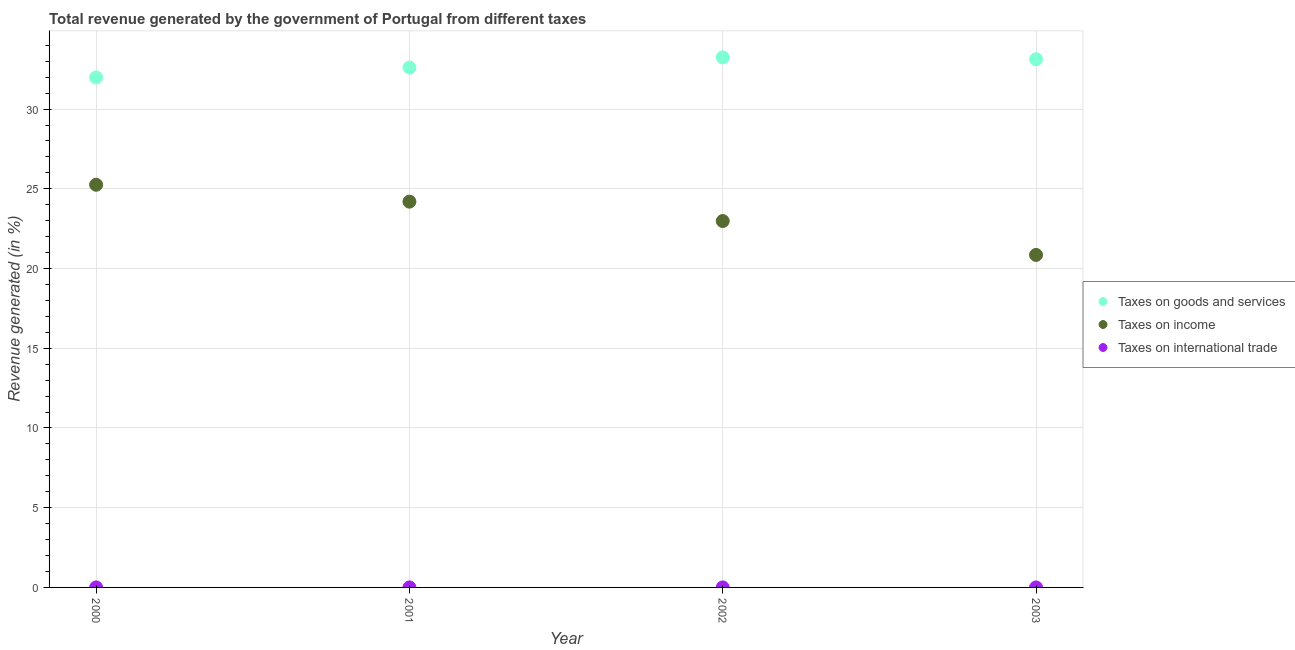How many different coloured dotlines are there?
Provide a short and direct response. 3. Is the number of dotlines equal to the number of legend labels?
Provide a succinct answer. Yes. What is the percentage of revenue generated by tax on international trade in 2000?
Your answer should be compact. 0. Across all years, what is the maximum percentage of revenue generated by taxes on income?
Your answer should be very brief. 25.25. Across all years, what is the minimum percentage of revenue generated by tax on international trade?
Offer a very short reply. 0. What is the total percentage of revenue generated by taxes on goods and services in the graph?
Keep it short and to the point. 130.96. What is the difference between the percentage of revenue generated by taxes on income in 2000 and that in 2002?
Offer a terse response. 2.28. What is the difference between the percentage of revenue generated by tax on international trade in 2002 and the percentage of revenue generated by taxes on income in 2000?
Your answer should be compact. -25.25. What is the average percentage of revenue generated by tax on international trade per year?
Your response must be concise. 0. In the year 2003, what is the difference between the percentage of revenue generated by tax on international trade and percentage of revenue generated by taxes on goods and services?
Offer a terse response. -33.12. In how many years, is the percentage of revenue generated by tax on international trade greater than 8 %?
Ensure brevity in your answer.  0. What is the ratio of the percentage of revenue generated by taxes on goods and services in 2002 to that in 2003?
Give a very brief answer. 1. Is the difference between the percentage of revenue generated by tax on international trade in 2002 and 2003 greater than the difference between the percentage of revenue generated by taxes on income in 2002 and 2003?
Ensure brevity in your answer.  No. What is the difference between the highest and the second highest percentage of revenue generated by taxes on income?
Your answer should be compact. 1.06. What is the difference between the highest and the lowest percentage of revenue generated by taxes on goods and services?
Offer a very short reply. 1.26. Does the percentage of revenue generated by taxes on income monotonically increase over the years?
Your answer should be compact. No. Is the percentage of revenue generated by tax on international trade strictly greater than the percentage of revenue generated by taxes on income over the years?
Offer a terse response. No. Is the percentage of revenue generated by taxes on goods and services strictly less than the percentage of revenue generated by tax on international trade over the years?
Offer a terse response. No. How many dotlines are there?
Offer a terse response. 3. How are the legend labels stacked?
Provide a short and direct response. Vertical. What is the title of the graph?
Give a very brief answer. Total revenue generated by the government of Portugal from different taxes. Does "Grants" appear as one of the legend labels in the graph?
Give a very brief answer. No. What is the label or title of the Y-axis?
Offer a very short reply. Revenue generated (in %). What is the Revenue generated (in %) of Taxes on goods and services in 2000?
Your answer should be compact. 31.98. What is the Revenue generated (in %) of Taxes on income in 2000?
Your answer should be compact. 25.25. What is the Revenue generated (in %) of Taxes on international trade in 2000?
Make the answer very short. 0. What is the Revenue generated (in %) of Taxes on goods and services in 2001?
Give a very brief answer. 32.6. What is the Revenue generated (in %) in Taxes on income in 2001?
Your answer should be very brief. 24.19. What is the Revenue generated (in %) of Taxes on international trade in 2001?
Offer a terse response. 0. What is the Revenue generated (in %) of Taxes on goods and services in 2002?
Your answer should be compact. 33.25. What is the Revenue generated (in %) of Taxes on income in 2002?
Keep it short and to the point. 22.98. What is the Revenue generated (in %) of Taxes on international trade in 2002?
Give a very brief answer. 0. What is the Revenue generated (in %) in Taxes on goods and services in 2003?
Give a very brief answer. 33.13. What is the Revenue generated (in %) in Taxes on income in 2003?
Your response must be concise. 20.85. What is the Revenue generated (in %) of Taxes on international trade in 2003?
Keep it short and to the point. 0. Across all years, what is the maximum Revenue generated (in %) of Taxes on goods and services?
Keep it short and to the point. 33.25. Across all years, what is the maximum Revenue generated (in %) of Taxes on income?
Offer a very short reply. 25.25. Across all years, what is the maximum Revenue generated (in %) of Taxes on international trade?
Your answer should be very brief. 0. Across all years, what is the minimum Revenue generated (in %) of Taxes on goods and services?
Provide a succinct answer. 31.98. Across all years, what is the minimum Revenue generated (in %) in Taxes on income?
Your answer should be compact. 20.85. Across all years, what is the minimum Revenue generated (in %) of Taxes on international trade?
Provide a succinct answer. 0. What is the total Revenue generated (in %) in Taxes on goods and services in the graph?
Give a very brief answer. 130.96. What is the total Revenue generated (in %) of Taxes on income in the graph?
Your answer should be compact. 93.28. What is the total Revenue generated (in %) of Taxes on international trade in the graph?
Make the answer very short. 0. What is the difference between the Revenue generated (in %) of Taxes on goods and services in 2000 and that in 2001?
Ensure brevity in your answer.  -0.62. What is the difference between the Revenue generated (in %) of Taxes on income in 2000 and that in 2001?
Give a very brief answer. 1.06. What is the difference between the Revenue generated (in %) of Taxes on goods and services in 2000 and that in 2002?
Give a very brief answer. -1.26. What is the difference between the Revenue generated (in %) in Taxes on income in 2000 and that in 2002?
Offer a very short reply. 2.28. What is the difference between the Revenue generated (in %) of Taxes on international trade in 2000 and that in 2002?
Offer a very short reply. 0. What is the difference between the Revenue generated (in %) of Taxes on goods and services in 2000 and that in 2003?
Offer a terse response. -1.14. What is the difference between the Revenue generated (in %) of Taxes on income in 2000 and that in 2003?
Your answer should be very brief. 4.4. What is the difference between the Revenue generated (in %) of Taxes on international trade in 2000 and that in 2003?
Your response must be concise. 0. What is the difference between the Revenue generated (in %) of Taxes on goods and services in 2001 and that in 2002?
Your answer should be very brief. -0.64. What is the difference between the Revenue generated (in %) in Taxes on income in 2001 and that in 2002?
Provide a succinct answer. 1.22. What is the difference between the Revenue generated (in %) in Taxes on goods and services in 2001 and that in 2003?
Give a very brief answer. -0.52. What is the difference between the Revenue generated (in %) in Taxes on income in 2001 and that in 2003?
Keep it short and to the point. 3.34. What is the difference between the Revenue generated (in %) of Taxes on goods and services in 2002 and that in 2003?
Your response must be concise. 0.12. What is the difference between the Revenue generated (in %) of Taxes on income in 2002 and that in 2003?
Make the answer very short. 2.13. What is the difference between the Revenue generated (in %) of Taxes on goods and services in 2000 and the Revenue generated (in %) of Taxes on income in 2001?
Offer a very short reply. 7.79. What is the difference between the Revenue generated (in %) in Taxes on goods and services in 2000 and the Revenue generated (in %) in Taxes on international trade in 2001?
Ensure brevity in your answer.  31.98. What is the difference between the Revenue generated (in %) of Taxes on income in 2000 and the Revenue generated (in %) of Taxes on international trade in 2001?
Give a very brief answer. 25.25. What is the difference between the Revenue generated (in %) in Taxes on goods and services in 2000 and the Revenue generated (in %) in Taxes on income in 2002?
Keep it short and to the point. 9.01. What is the difference between the Revenue generated (in %) in Taxes on goods and services in 2000 and the Revenue generated (in %) in Taxes on international trade in 2002?
Offer a very short reply. 31.98. What is the difference between the Revenue generated (in %) of Taxes on income in 2000 and the Revenue generated (in %) of Taxes on international trade in 2002?
Your answer should be compact. 25.25. What is the difference between the Revenue generated (in %) in Taxes on goods and services in 2000 and the Revenue generated (in %) in Taxes on income in 2003?
Make the answer very short. 11.13. What is the difference between the Revenue generated (in %) in Taxes on goods and services in 2000 and the Revenue generated (in %) in Taxes on international trade in 2003?
Provide a short and direct response. 31.98. What is the difference between the Revenue generated (in %) of Taxes on income in 2000 and the Revenue generated (in %) of Taxes on international trade in 2003?
Your response must be concise. 25.25. What is the difference between the Revenue generated (in %) of Taxes on goods and services in 2001 and the Revenue generated (in %) of Taxes on income in 2002?
Provide a short and direct response. 9.62. What is the difference between the Revenue generated (in %) in Taxes on goods and services in 2001 and the Revenue generated (in %) in Taxes on international trade in 2002?
Your answer should be very brief. 32.6. What is the difference between the Revenue generated (in %) of Taxes on income in 2001 and the Revenue generated (in %) of Taxes on international trade in 2002?
Make the answer very short. 24.19. What is the difference between the Revenue generated (in %) of Taxes on goods and services in 2001 and the Revenue generated (in %) of Taxes on income in 2003?
Make the answer very short. 11.75. What is the difference between the Revenue generated (in %) of Taxes on goods and services in 2001 and the Revenue generated (in %) of Taxes on international trade in 2003?
Make the answer very short. 32.6. What is the difference between the Revenue generated (in %) in Taxes on income in 2001 and the Revenue generated (in %) in Taxes on international trade in 2003?
Your response must be concise. 24.19. What is the difference between the Revenue generated (in %) in Taxes on goods and services in 2002 and the Revenue generated (in %) in Taxes on income in 2003?
Your answer should be very brief. 12.39. What is the difference between the Revenue generated (in %) of Taxes on goods and services in 2002 and the Revenue generated (in %) of Taxes on international trade in 2003?
Give a very brief answer. 33.24. What is the difference between the Revenue generated (in %) of Taxes on income in 2002 and the Revenue generated (in %) of Taxes on international trade in 2003?
Offer a terse response. 22.98. What is the average Revenue generated (in %) of Taxes on goods and services per year?
Offer a terse response. 32.74. What is the average Revenue generated (in %) in Taxes on income per year?
Offer a very short reply. 23.32. What is the average Revenue generated (in %) of Taxes on international trade per year?
Offer a terse response. 0. In the year 2000, what is the difference between the Revenue generated (in %) in Taxes on goods and services and Revenue generated (in %) in Taxes on income?
Ensure brevity in your answer.  6.73. In the year 2000, what is the difference between the Revenue generated (in %) of Taxes on goods and services and Revenue generated (in %) of Taxes on international trade?
Make the answer very short. 31.98. In the year 2000, what is the difference between the Revenue generated (in %) of Taxes on income and Revenue generated (in %) of Taxes on international trade?
Provide a succinct answer. 25.25. In the year 2001, what is the difference between the Revenue generated (in %) in Taxes on goods and services and Revenue generated (in %) in Taxes on income?
Keep it short and to the point. 8.41. In the year 2001, what is the difference between the Revenue generated (in %) in Taxes on goods and services and Revenue generated (in %) in Taxes on international trade?
Your answer should be compact. 32.6. In the year 2001, what is the difference between the Revenue generated (in %) in Taxes on income and Revenue generated (in %) in Taxes on international trade?
Provide a succinct answer. 24.19. In the year 2002, what is the difference between the Revenue generated (in %) in Taxes on goods and services and Revenue generated (in %) in Taxes on income?
Offer a very short reply. 10.27. In the year 2002, what is the difference between the Revenue generated (in %) in Taxes on goods and services and Revenue generated (in %) in Taxes on international trade?
Provide a succinct answer. 33.24. In the year 2002, what is the difference between the Revenue generated (in %) in Taxes on income and Revenue generated (in %) in Taxes on international trade?
Offer a terse response. 22.98. In the year 2003, what is the difference between the Revenue generated (in %) in Taxes on goods and services and Revenue generated (in %) in Taxes on income?
Make the answer very short. 12.27. In the year 2003, what is the difference between the Revenue generated (in %) of Taxes on goods and services and Revenue generated (in %) of Taxes on international trade?
Make the answer very short. 33.12. In the year 2003, what is the difference between the Revenue generated (in %) of Taxes on income and Revenue generated (in %) of Taxes on international trade?
Your response must be concise. 20.85. What is the ratio of the Revenue generated (in %) of Taxes on goods and services in 2000 to that in 2001?
Provide a short and direct response. 0.98. What is the ratio of the Revenue generated (in %) of Taxes on income in 2000 to that in 2001?
Ensure brevity in your answer.  1.04. What is the ratio of the Revenue generated (in %) in Taxes on international trade in 2000 to that in 2001?
Your answer should be very brief. 1.48. What is the ratio of the Revenue generated (in %) in Taxes on goods and services in 2000 to that in 2002?
Ensure brevity in your answer.  0.96. What is the ratio of the Revenue generated (in %) of Taxes on income in 2000 to that in 2002?
Offer a terse response. 1.1. What is the ratio of the Revenue generated (in %) of Taxes on international trade in 2000 to that in 2002?
Provide a succinct answer. 1.44. What is the ratio of the Revenue generated (in %) in Taxes on goods and services in 2000 to that in 2003?
Your response must be concise. 0.97. What is the ratio of the Revenue generated (in %) of Taxes on income in 2000 to that in 2003?
Your response must be concise. 1.21. What is the ratio of the Revenue generated (in %) of Taxes on international trade in 2000 to that in 2003?
Offer a very short reply. 1.86. What is the ratio of the Revenue generated (in %) in Taxes on goods and services in 2001 to that in 2002?
Provide a short and direct response. 0.98. What is the ratio of the Revenue generated (in %) of Taxes on income in 2001 to that in 2002?
Keep it short and to the point. 1.05. What is the ratio of the Revenue generated (in %) in Taxes on international trade in 2001 to that in 2002?
Keep it short and to the point. 0.98. What is the ratio of the Revenue generated (in %) of Taxes on goods and services in 2001 to that in 2003?
Make the answer very short. 0.98. What is the ratio of the Revenue generated (in %) in Taxes on income in 2001 to that in 2003?
Your response must be concise. 1.16. What is the ratio of the Revenue generated (in %) in Taxes on international trade in 2001 to that in 2003?
Your response must be concise. 1.26. What is the ratio of the Revenue generated (in %) of Taxes on income in 2002 to that in 2003?
Provide a succinct answer. 1.1. What is the ratio of the Revenue generated (in %) of Taxes on international trade in 2002 to that in 2003?
Provide a short and direct response. 1.29. What is the difference between the highest and the second highest Revenue generated (in %) in Taxes on goods and services?
Offer a very short reply. 0.12. What is the difference between the highest and the second highest Revenue generated (in %) of Taxes on income?
Offer a very short reply. 1.06. What is the difference between the highest and the lowest Revenue generated (in %) of Taxes on goods and services?
Keep it short and to the point. 1.26. What is the difference between the highest and the lowest Revenue generated (in %) in Taxes on income?
Your answer should be compact. 4.4. What is the difference between the highest and the lowest Revenue generated (in %) of Taxes on international trade?
Ensure brevity in your answer.  0. 